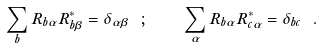<formula> <loc_0><loc_0><loc_500><loc_500>\sum _ { b } R _ { b \alpha } R _ { b \beta } ^ { * } = \delta _ { \alpha \beta } \ ; \quad \sum _ { \alpha } R _ { b \alpha } R _ { c \alpha } ^ { * } = \delta _ { b c } \ .</formula> 